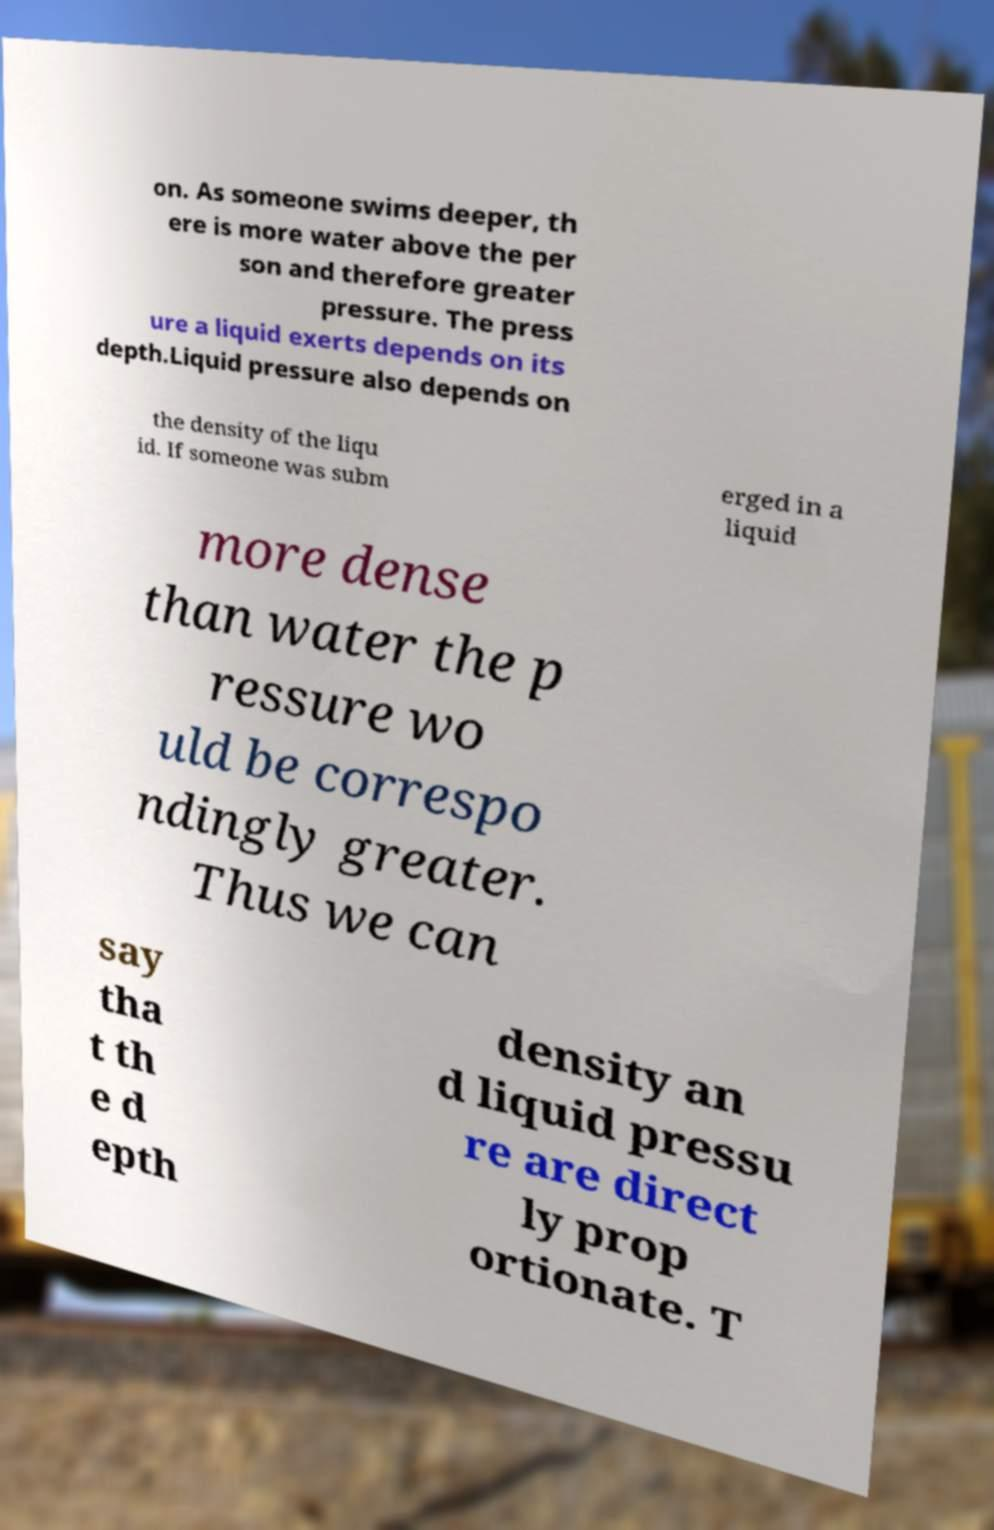Please identify and transcribe the text found in this image. on. As someone swims deeper, th ere is more water above the per son and therefore greater pressure. The press ure a liquid exerts depends on its depth.Liquid pressure also depends on the density of the liqu id. If someone was subm erged in a liquid more dense than water the p ressure wo uld be correspo ndingly greater. Thus we can say tha t th e d epth density an d liquid pressu re are direct ly prop ortionate. T 